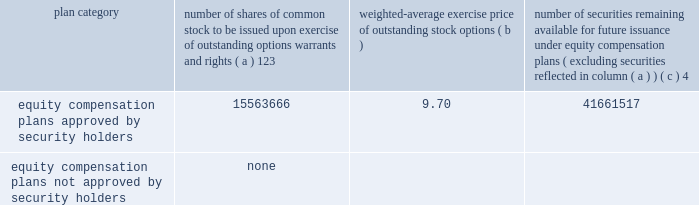Part iii item 10 .
Directors , executive officers and corporate governance the information required by this item is incorporated by reference to the 201celection of directors 201d section , the 201cdirector selection process 201d section , the 201ccode of conduct 201d section , the 201cprincipal committees of the board of directors 201d section , the 201caudit committee 201d section and the 201csection 16 ( a ) beneficial ownership reporting compliance 201d section of the proxy statement for the annual meeting of stockholders to be held on may 21 , 2015 ( the 201cproxy statement 201d ) , except for the description of our executive officers , which appears in part i of this report on form 10-k under the heading 201cexecutive officers of ipg . 201d new york stock exchange certification in 2014 , our chief executive officer provided the annual ceo certification to the new york stock exchange , as required under section 303a.12 ( a ) of the new york stock exchange listed company manual .
Item 11 .
Executive compensation the information required by this item is incorporated by reference to the 201cexecutive compensation 201d section , the 201cnon- management director compensation 201d section , the 201ccompensation discussion and analysis 201d section and the 201ccompensation and leadership talent committee report 201d section of the proxy statement .
Item 12 .
Security ownership of certain beneficial owners and management and related stockholder matters the information required by this item is incorporated by reference to the 201coutstanding shares and ownership of common stock 201d section of the proxy statement , except for information regarding the shares of common stock to be issued or which may be issued under our equity compensation plans as of december 31 , 2014 , which is provided in the table .
Equity compensation plan information plan category number of shares of common stock to be issued upon exercise of outstanding options , warrants and rights ( a ) 123 weighted-average exercise price of outstanding stock options number of securities remaining available for future issuance under equity compensation plans ( excluding securities reflected in column ( a ) ) equity compensation plans approved by security holders .
15563666 9.70 41661517 equity compensation plans not approved by security holders .
None 1 included a total of 5866475 performance-based share awards made under the 2009 and 2014 performance incentive plans representing the target number of shares of common stock to be issued to employees following the completion of the 2012-2014 performance period ( the 201c2014 ltip share awards 201d ) , the 2013-2015 performance period ( the 201c2015 ltip share awards 201d ) and the 2014-2016 performance period ( the 201c2016 ltip share awards 201d ) , respectively .
The computation of the weighted-average exercise price in column ( b ) of this table does not take the 2014 ltip share awards , the 2015 ltip share awards or the 2016 ltip share awards into account .
2 included a total of 98877 restricted share units and performance-based awards ( 201cshare unit awards 201d ) which may be settled in shares of common stock or cash .
The computation of the weighted-average exercise price in column ( b ) of this table does not take the share unit awards into account .
Each share unit award actually settled in cash will increase the number of shares of common stock available for issuance shown in column ( c ) .
3 ipg has issued restricted cash awards ( 201cperformance cash awards 201d ) , half of which shall be settled in shares of common stock and half of which shall be settled in cash .
Using the 2014 closing stock price of $ 20.77 , the awards which shall be settled in shares of common stock represent rights to an additional 2721405 shares .
These shares are not included in the table above .
4 included ( i ) 29045044 shares of common stock available for issuance under the 2014 performance incentive plan , ( ii ) 12181214 shares of common stock available for issuance under the employee stock purchase plan ( 2006 ) and ( iii ) 435259 shares of common stock available for issuance under the 2009 non-management directors 2019 stock incentive plan. .
Part iii item 10 .
Directors , executive officers and corporate governance the information required by this item is incorporated by reference to the 201celection of directors 201d section , the 201cdirector selection process 201d section , the 201ccode of conduct 201d section , the 201cprincipal committees of the board of directors 201d section , the 201caudit committee 201d section and the 201csection 16 ( a ) beneficial ownership reporting compliance 201d section of the proxy statement for the annual meeting of stockholders to be held on may 21 , 2015 ( the 201cproxy statement 201d ) , except for the description of our executive officers , which appears in part i of this report on form 10-k under the heading 201cexecutive officers of ipg . 201d new york stock exchange certification in 2014 , our chief executive officer provided the annual ceo certification to the new york stock exchange , as required under section 303a.12 ( a ) of the new york stock exchange listed company manual .
Item 11 .
Executive compensation the information required by this item is incorporated by reference to the 201cexecutive compensation 201d section , the 201cnon- management director compensation 201d section , the 201ccompensation discussion and analysis 201d section and the 201ccompensation and leadership talent committee report 201d section of the proxy statement .
Item 12 .
Security ownership of certain beneficial owners and management and related stockholder matters the information required by this item is incorporated by reference to the 201coutstanding shares and ownership of common stock 201d section of the proxy statement , except for information regarding the shares of common stock to be issued or which may be issued under our equity compensation plans as of december 31 , 2014 , which is provided in the following table .
Equity compensation plan information plan category number of shares of common stock to be issued upon exercise of outstanding options , warrants and rights ( a ) 123 weighted-average exercise price of outstanding stock options number of securities remaining available for future issuance under equity compensation plans ( excluding securities reflected in column ( a ) ) equity compensation plans approved by security holders .
15563666 9.70 41661517 equity compensation plans not approved by security holders .
None 1 included a total of 5866475 performance-based share awards made under the 2009 and 2014 performance incentive plans representing the target number of shares of common stock to be issued to employees following the completion of the 2012-2014 performance period ( the 201c2014 ltip share awards 201d ) , the 2013-2015 performance period ( the 201c2015 ltip share awards 201d ) and the 2014-2016 performance period ( the 201c2016 ltip share awards 201d ) , respectively .
The computation of the weighted-average exercise price in column ( b ) of this table does not take the 2014 ltip share awards , the 2015 ltip share awards or the 2016 ltip share awards into account .
2 included a total of 98877 restricted share units and performance-based awards ( 201cshare unit awards 201d ) which may be settled in shares of common stock or cash .
The computation of the weighted-average exercise price in column ( b ) of this table does not take the share unit awards into account .
Each share unit award actually settled in cash will increase the number of shares of common stock available for issuance shown in column ( c ) .
3 ipg has issued restricted cash awards ( 201cperformance cash awards 201d ) , half of which shall be settled in shares of common stock and half of which shall be settled in cash .
Using the 2014 closing stock price of $ 20.77 , the awards which shall be settled in shares of common stock represent rights to an additional 2721405 shares .
These shares are not included in the table above .
4 included ( i ) 29045044 shares of common stock available for issuance under the 2014 performance incentive plan , ( ii ) 12181214 shares of common stock available for issuance under the employee stock purchase plan ( 2006 ) and ( iii ) 435259 shares of common stock available for issuance under the 2009 non-management directors 2019 stock incentive plan. .
With 2014 closing stock price , what is the total value of the award for the additional shares , ( in millions ) ? 
Computations: ((2721405 * 20.77) / 1000000)
Answer: 56.52358. 